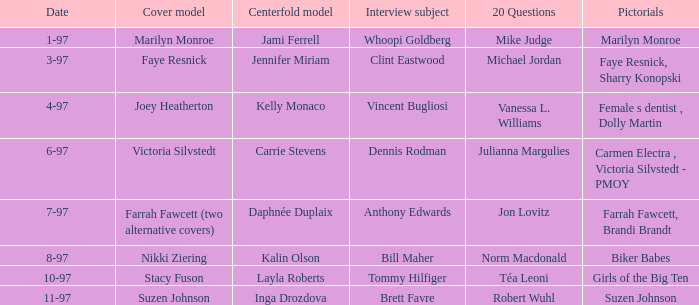Who was the interview subject on the date 1-97? Whoopi Goldberg. 